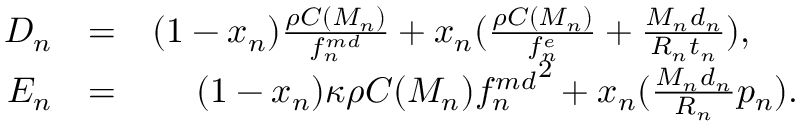<formula> <loc_0><loc_0><loc_500><loc_500>\begin{array} { r l r } { D _ { n } } & { = } & { ( 1 - x _ { n } ) \frac { \rho C ( M _ { n } ) } { f _ { n } ^ { m d } } + x _ { n } ( \frac { \rho C ( M _ { n } ) } { f _ { n } ^ { e } } + \frac { M _ { n } d _ { n } } { R _ { n } t _ { n } } ) , \quad } \\ { E _ { n } } & { = } & { ( 1 - x _ { n } ) \kappa \rho C ( M _ { n } ) { f _ { n } ^ { m d } } ^ { 2 } + x _ { n } ( \frac { M _ { n } d _ { n } } { R _ { n } } p _ { n } ) . } \end{array}</formula> 